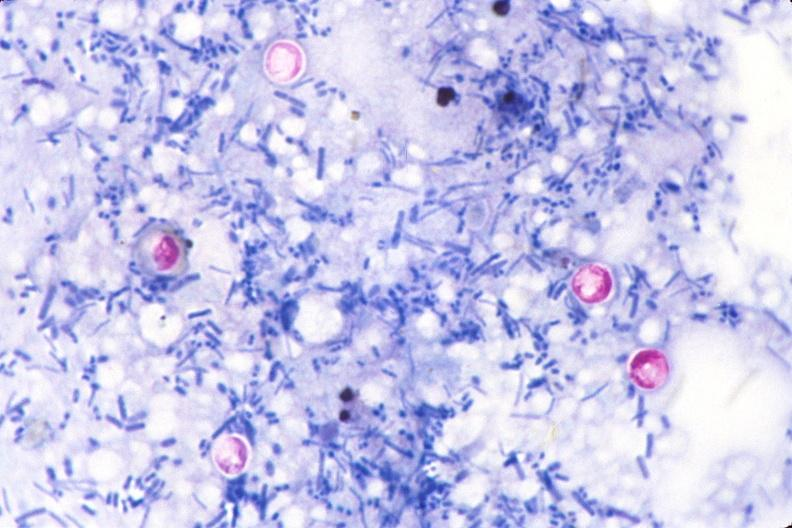does acid stain of feces?
Answer the question using a single word or phrase. Yes 